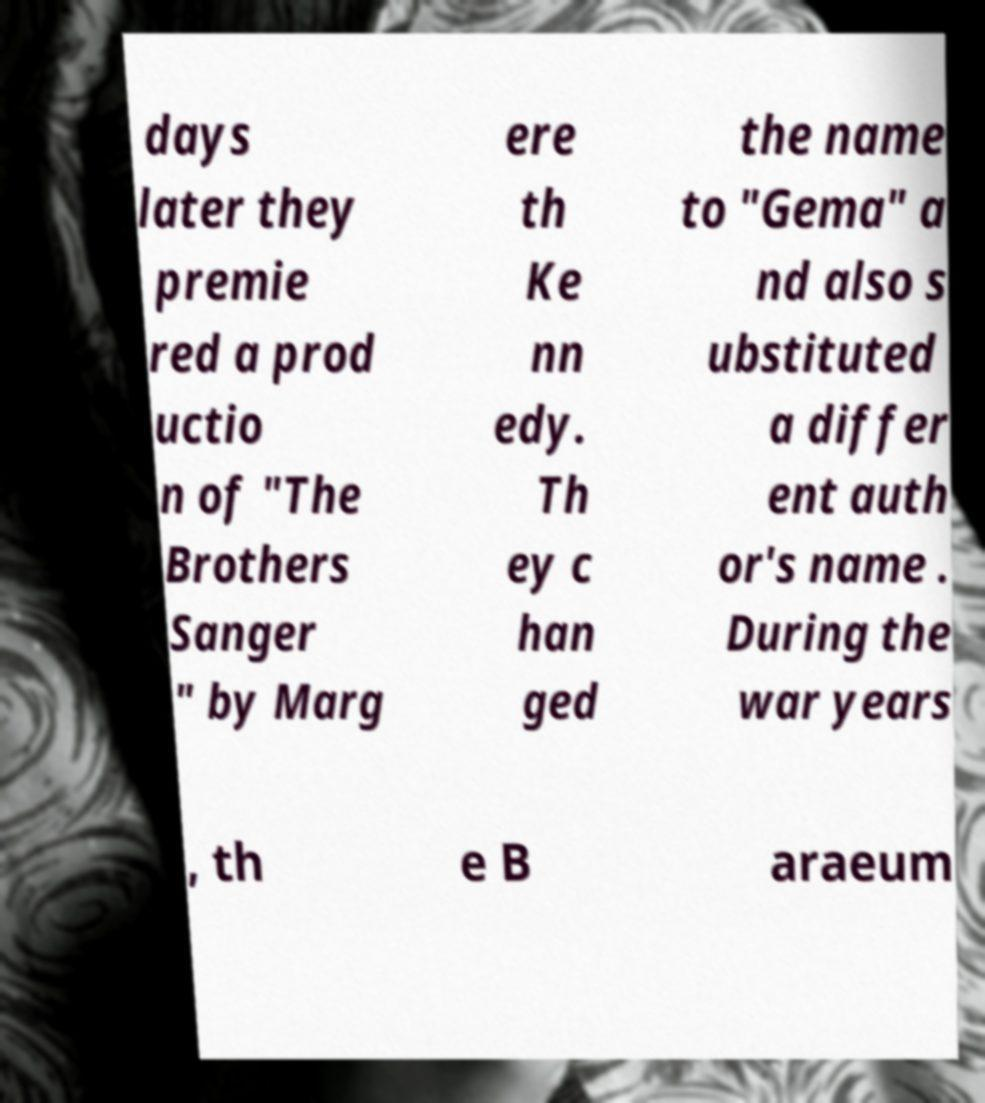I need the written content from this picture converted into text. Can you do that? days later they premie red a prod uctio n of "The Brothers Sanger " by Marg ere th Ke nn edy. Th ey c han ged the name to "Gema" a nd also s ubstituted a differ ent auth or's name . During the war years , th e B araeum 